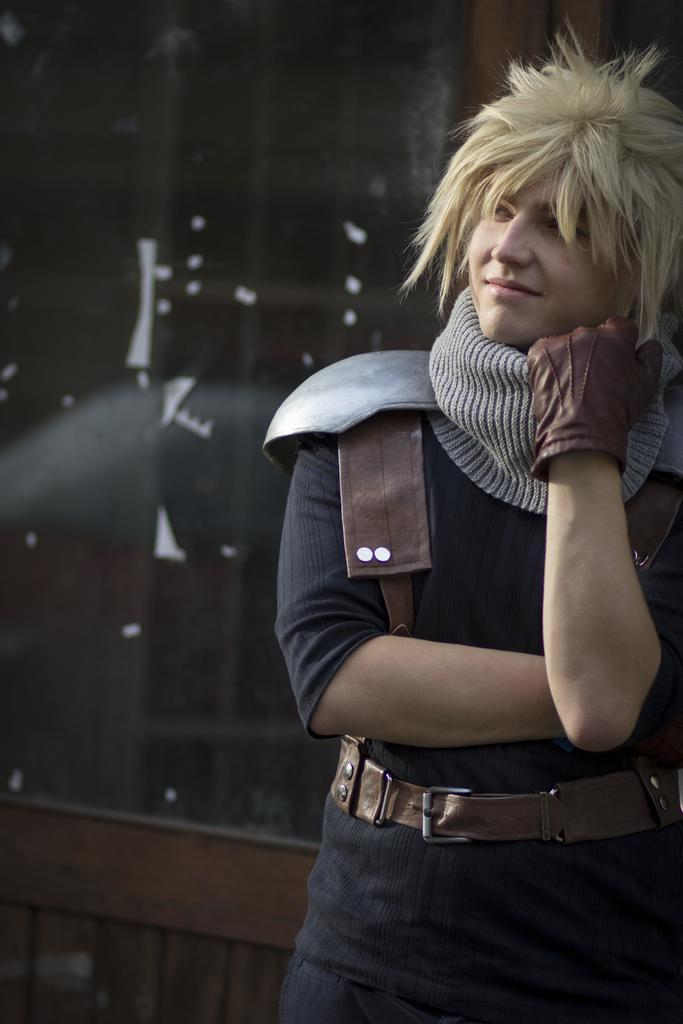Who or what is present in the image? There is a person in the image. What is the person doing in the image? The person is standing in the image. What is the person's facial expression in the image? The person is smiling in the image. What clothing items can be seen on the person in the image? The person is wearing a glove and a belt in the image. What type of sheet is being used to control the person's impulses in the image? There is no sheet or impulse control mentioned in the image; it only shows a person standing, smiling, and wearing a glove and a belt. 